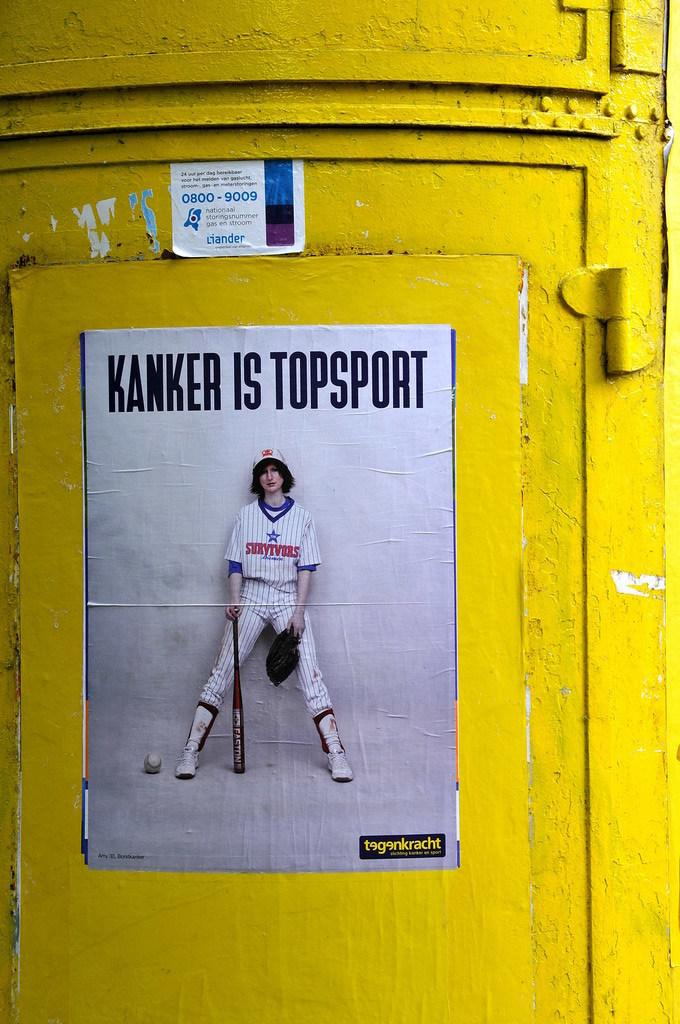<image>
Offer a succinct explanation of the picture presented. A baseball poster with the words "Kanker is Topsport." printed on a tellow pole. 